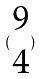<formula> <loc_0><loc_0><loc_500><loc_500>( \begin{matrix} 9 \\ 4 \end{matrix} )</formula> 